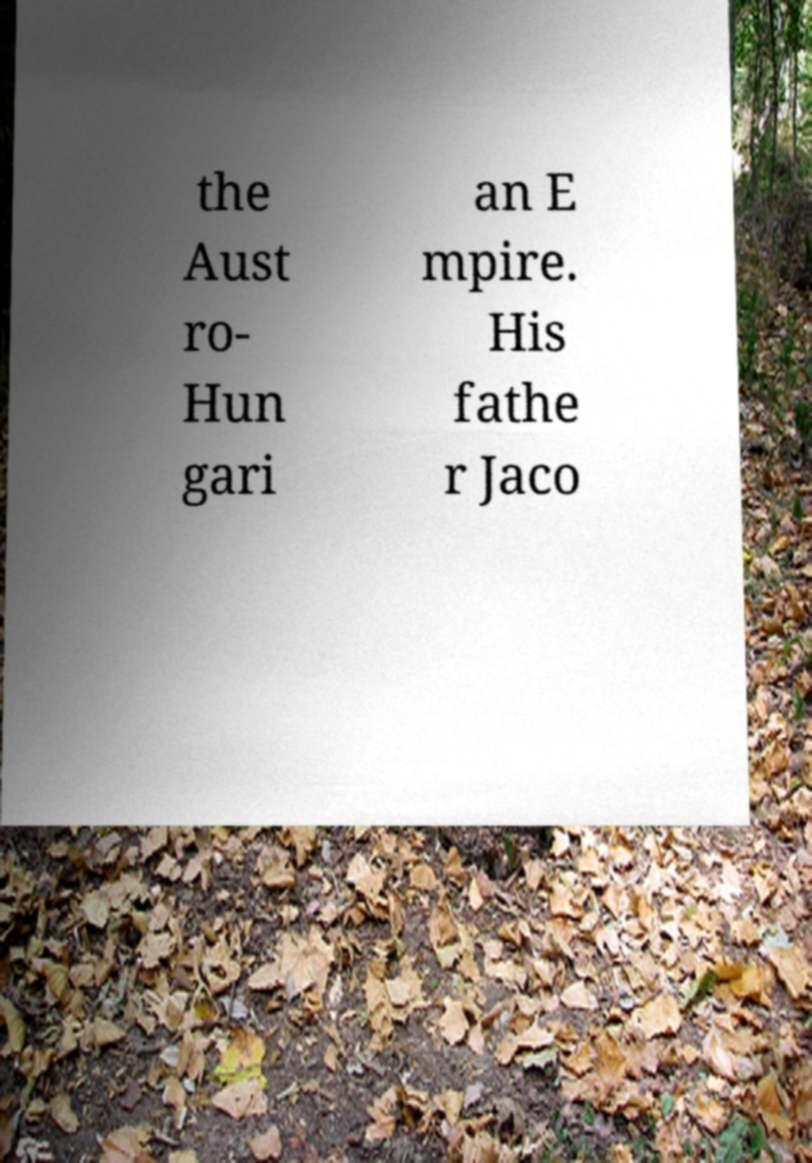Please identify and transcribe the text found in this image. the Aust ro- Hun gari an E mpire. His fathe r Jaco 